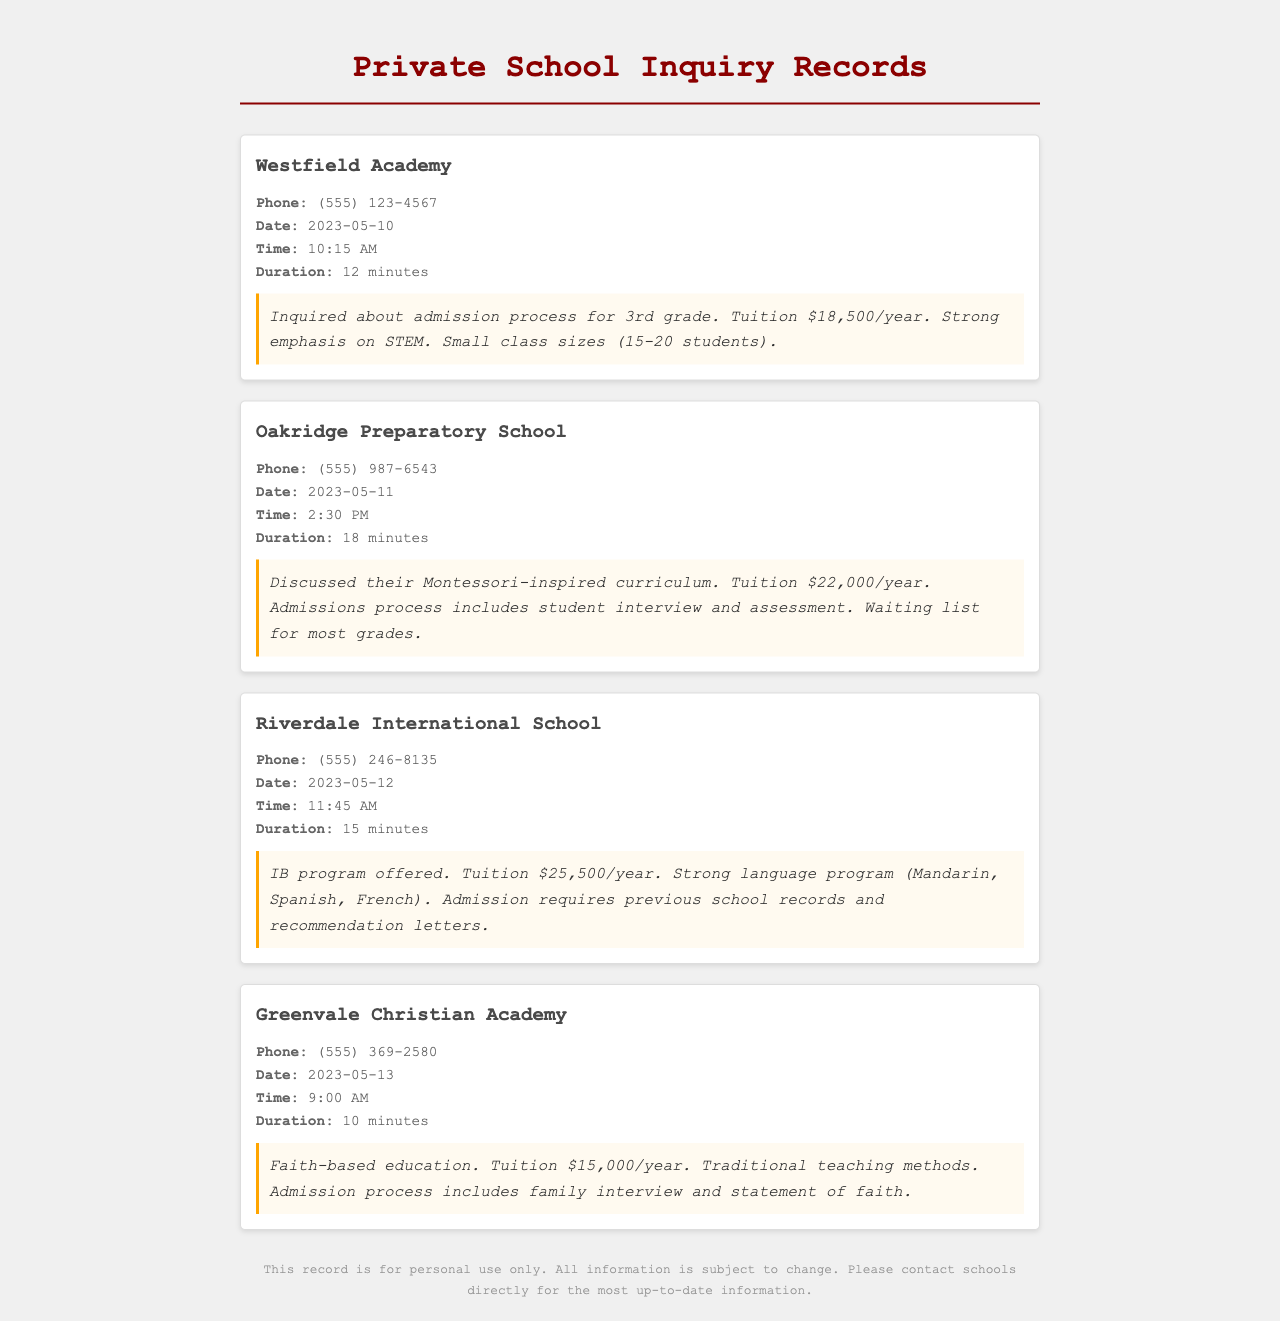What is the tuition for Westfield Academy? The tuition for Westfield Academy is mentioned within the document as $18,500/year.
Answer: $18,500/year What educational philosophy is emphasized at Oakridge Preparatory School? The document notes that Oakridge Preparatory School has a Montessori-inspired curriculum.
Answer: Montessori-inspired curriculum What is the phone number for Riverdale International School? The phone number for Riverdale International School is provided as (555) 246-8135.
Answer: (555) 246-8135 How long was the call with Greenvale Christian Academy? The document states that the duration of the call with Greenvale Christian Academy was 10 minutes.
Answer: 10 minutes What is required for admission to Riverdale International School? The document lists the admission requirements for Riverdale International School as previous school records and recommendation letters.
Answer: Previous school records and recommendation letters Which school has a waiting list for most grades? According to the document, Oakridge Preparatory School has a waiting list for most grades.
Answer: Oakridge Preparatory School What is the strong language program offered at Riverdale International School? The document mentions that Riverdale International School offers a strong language program in Mandarin, Spanish, and French.
Answer: Mandarin, Spanish, French What type of education does Greenvale Christian Academy provide? The document describes the education provided by Greenvale Christian Academy as faith-based.
Answer: Faith-based What date was the first call made? The document indicates that the first call was made on May 10, 2023.
Answer: May 10, 2023 